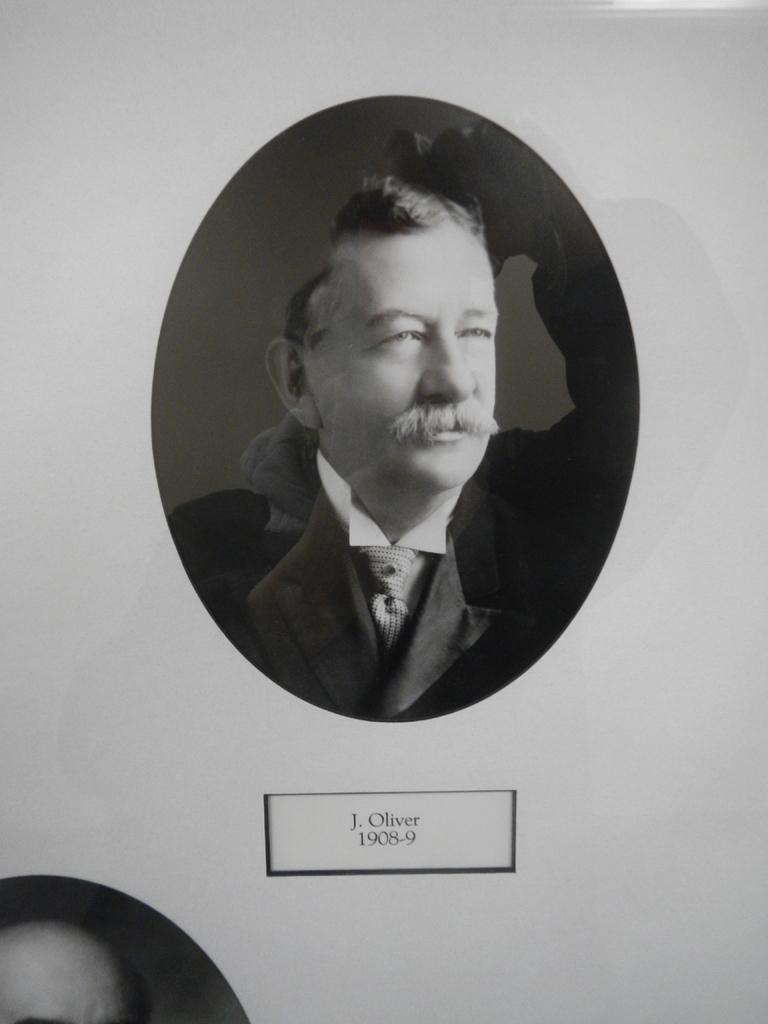What is the main subject of the image? There is a photograph of a man in the image. What is the man wearing in the image? The man is wearing a black suit and a white shirt. What is present at the bottom of the image? There is text at the bottom of the image. What is the text written on? The text appears to be on a paper. Can you see any yaks in the image? A: No, there are no yaks present in the image. Is the man in the image taking a rest? The image does not provide information about the man's actions or state of rest. Is the paper on fire in the image? No, there is no indication that the paper is burning or on fire in the image. 